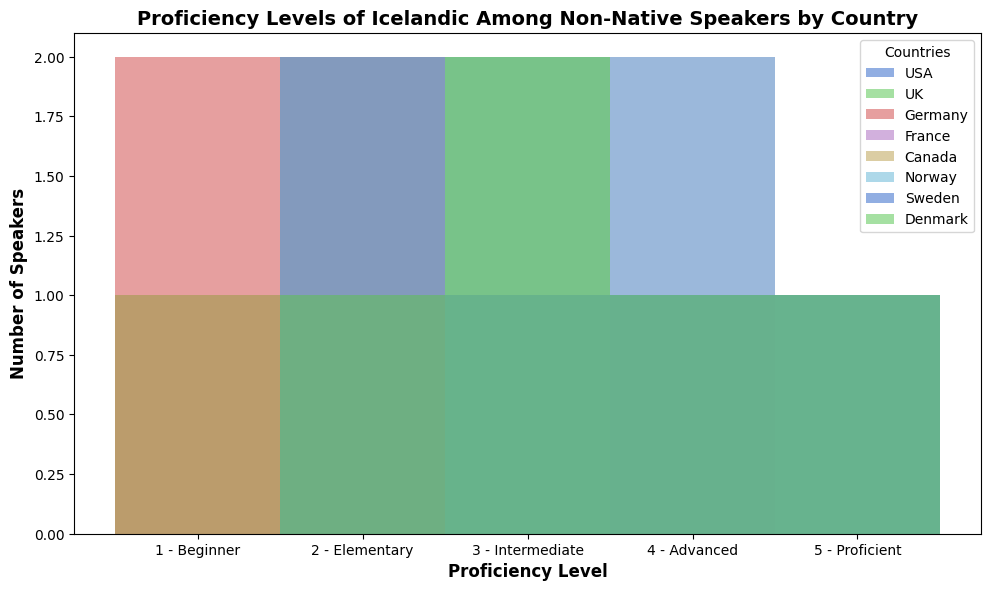What is the most common proficiency level for speakers from the USA? To determine the most common proficiency level for speakers from the USA, look at the bars representing the USA and find the tallest one.
Answer: 3 Which country has the most speakers at the "Proficient" level? Find the bars labeled "Proficient" for each country and identify the tallest one.
Answer: UK Which proficiency level is least common among speakers from Germany? Look at the bars for Germany and find the shortest one.
Answer: 4 Are there more speakers at the "Intermediate" level in Canada or Norway? Compare the height of the "Intermediate" level bars for Canada and Norway.
Answer: Canada What is the average proficiency level for speakers from France? Identify the proficiency levels for France (5, 4, 3, 4, 2), sum them (5 + 4 + 3 + 4 + 2 = 18), and divide by the number of data points (18/5 = 3.6).
Answer: 3.6 How many speakers from Sweden are at the "Elementary" level? Look at the "Elementary" level bar for Sweden and note its height.
Answer: 2 Which country has the greatest range of proficiency levels among its speakers? Identify the range (max - min proficiency levels) for each country and see which has the largest difference. Consider all levels from 1 to 5.
Answer: All countries (identical range) Do more people in Denmark or Germany have an "Advanced" proficiency level? Compare the heights of the "Advanced" bars for Denmark and Germany.
Answer: Denmark What is the sum of all "Beginner" level speakers across all countries? Sum the heights of the "Beginner" level bars for all countries.
Answer: 6 How does the number of "Intermediate" speakers in the USA compare to those in the UK? Compare the heights of the "Intermediate" bars for the USA and UK.
Answer: USA has more 